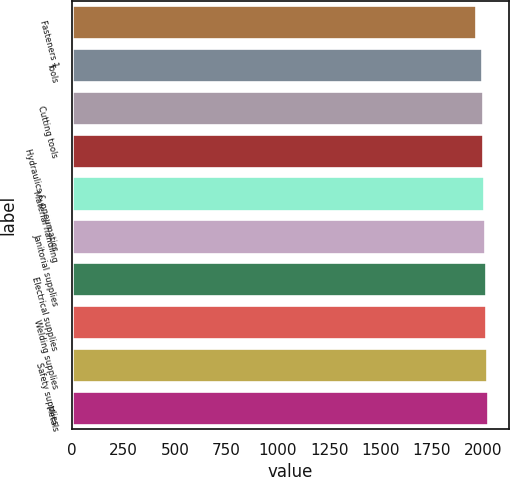Convert chart to OTSL. <chart><loc_0><loc_0><loc_500><loc_500><bar_chart><fcel>Fasteners 1<fcel>Tools<fcel>Cutting tools<fcel>Hydraulics & pneumatics<fcel>Material handling<fcel>Janitorial supplies<fcel>Electrical supplies<fcel>Welding supplies<fcel>Safety supplies<fcel>Metals<nl><fcel>1967<fcel>1993<fcel>1996.7<fcel>2000.4<fcel>2004.1<fcel>2007.8<fcel>2011.5<fcel>2015.2<fcel>2018.9<fcel>2022.6<nl></chart> 